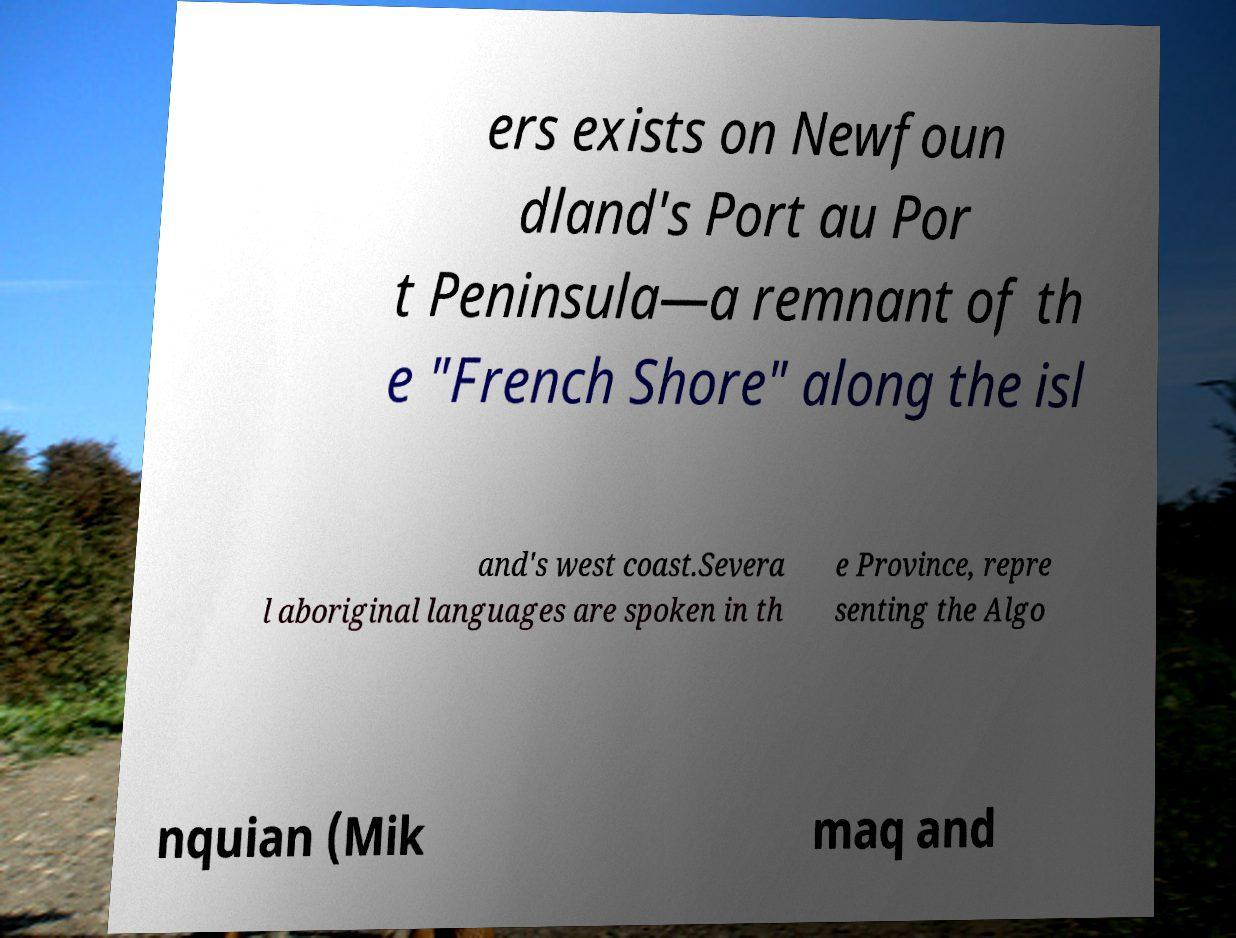For documentation purposes, I need the text within this image transcribed. Could you provide that? ers exists on Newfoun dland's Port au Por t Peninsula—a remnant of th e "French Shore" along the isl and's west coast.Severa l aboriginal languages are spoken in th e Province, repre senting the Algo nquian (Mik maq and 